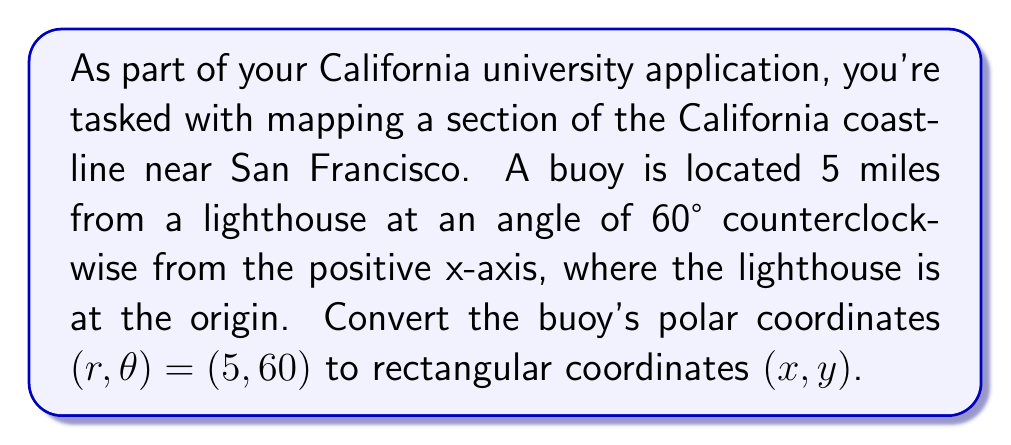Give your solution to this math problem. To convert polar coordinates $(r, \theta)$ to rectangular coordinates $(x, y)$, we use the following formulas:

$$x = r \cos(\theta)$$
$$y = r \sin(\theta)$$

Given:
$r = 5$ miles
$\theta = 60°$

Step 1: Calculate x-coordinate
$$x = r \cos(\theta)$$
$$x = 5 \cos(60°)$$
$$x = 5 \cdot \frac{1}{2} = 2.5$$

Step 2: Calculate y-coordinate
$$y = r \sin(\theta)$$
$$y = 5 \sin(60°)$$
$$y = 5 \cdot \frac{\sqrt{3}}{2} = 5 \cdot \frac{\sqrt{3}}{2} \approx 4.33$$

Therefore, the rectangular coordinates of the buoy are approximately (2.5, 4.33) miles.

[asy]
import geometry;

unitsize(1cm);

pair O=(0,0);
pair A=(2.5,4.33);

draw(O--A,arrow=Arrow(TeXHead));
draw(arc(O,1,0,60),arrow=Arrow(TeXHead));

dot("Lighthouse",O,SW);
dot("Buoy",A,NE);

label("5 miles",O--A,NW);
label("60°",(0.5,0.3),NE);

draw(O--(2.5,0),dashed);
draw((2.5,0)--A,dashed);

label("x",(5,0),E);
label("y",(0,5),N);

[/asy]
Answer: The rectangular coordinates of the buoy are approximately $(2.5, 4.33)$ miles. 